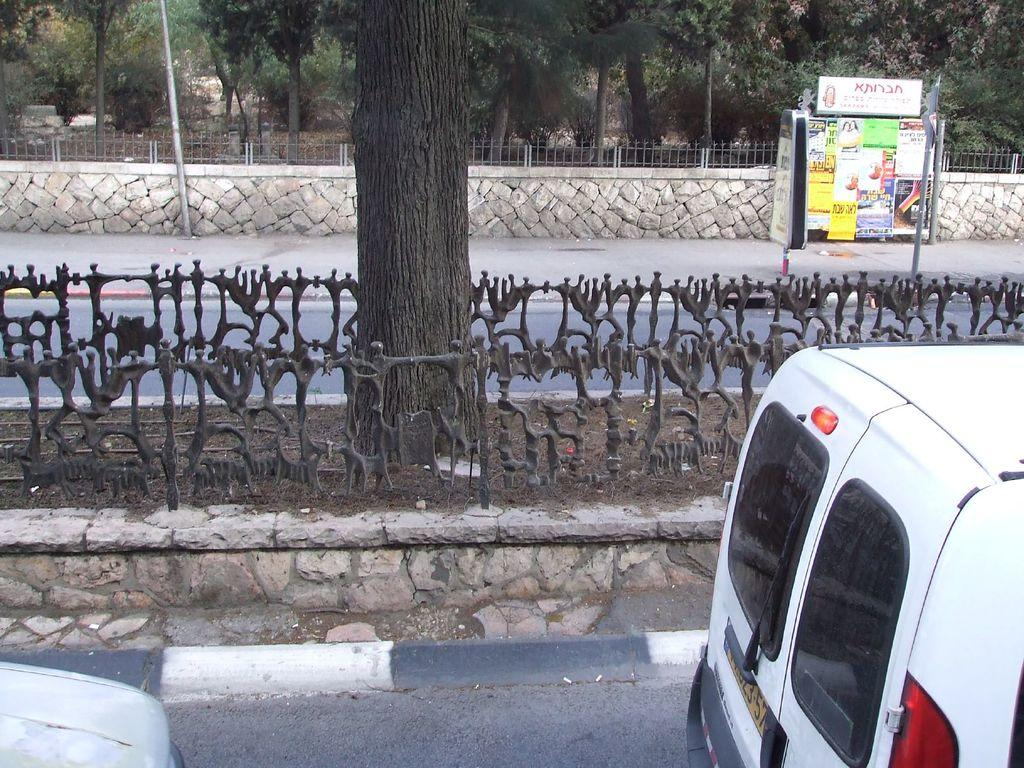What can be seen on the road in the image? There are vehicles on the road in the image. What type of structures can be seen in the image? There are fences and poles in the image. What is displayed on the structures in the image? There are posters on the poles in the image. What type of vegetation is visible in the background of the image? There are trees visible in the background of the image. What type of quartz can be seen in the image? There is no quartz present in the image. How does the organization affect the vehicles on the road in the image? There is no mention of an organization in the image, and therefore its impact on the vehicles cannot be determined. 